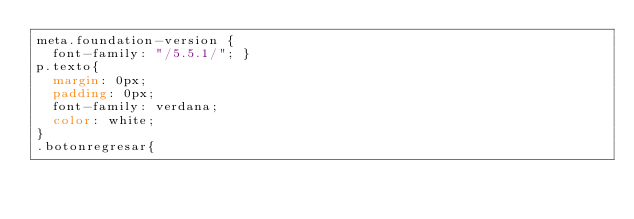Convert code to text. <code><loc_0><loc_0><loc_500><loc_500><_CSS_>meta.foundation-version {
  font-family: "/5.5.1/"; }
p.texto{
	margin: 0px;
	padding: 0px;
	font-family: verdana;
	color: white;
}
.botonregresar{</code> 